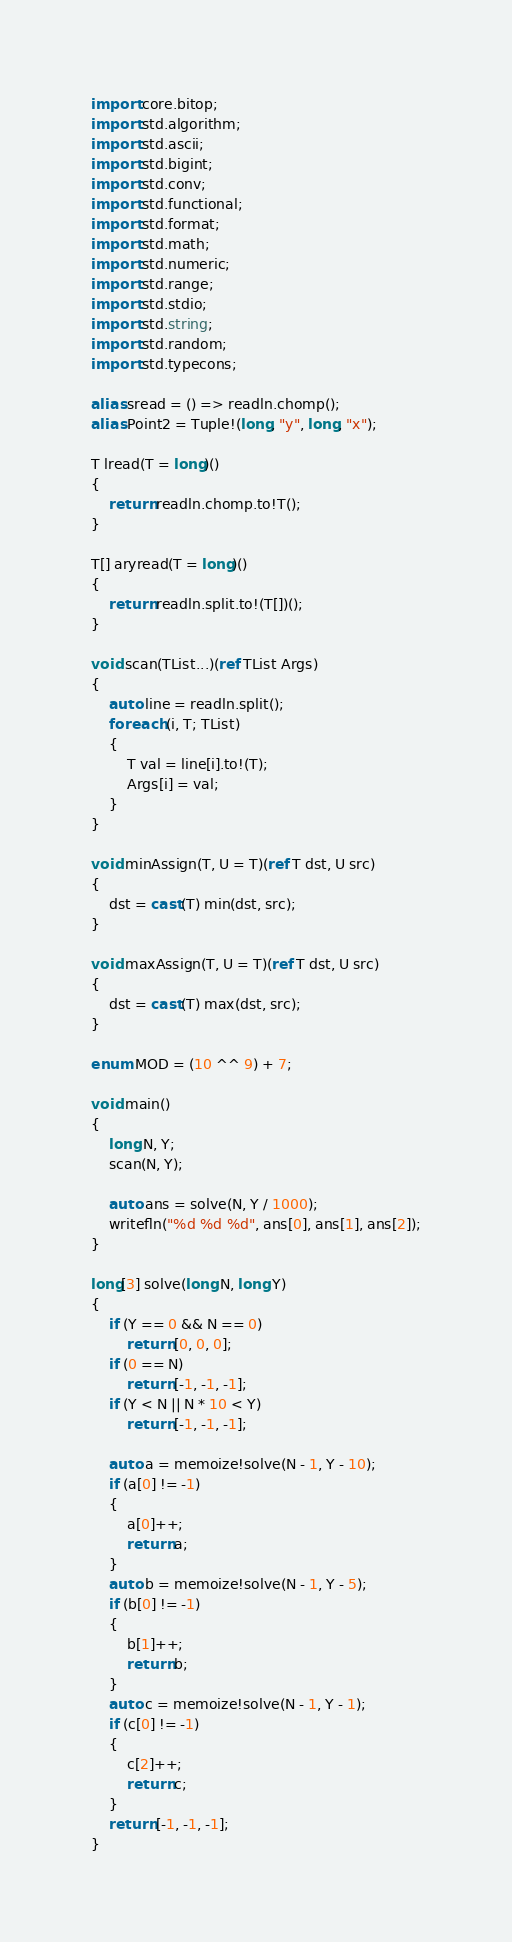<code> <loc_0><loc_0><loc_500><loc_500><_D_>import core.bitop;
import std.algorithm;
import std.ascii;
import std.bigint;
import std.conv;
import std.functional;
import std.format;
import std.math;
import std.numeric;
import std.range;
import std.stdio;
import std.string;
import std.random;
import std.typecons;

alias sread = () => readln.chomp();
alias Point2 = Tuple!(long, "y", long, "x");

T lread(T = long)()
{
    return readln.chomp.to!T();
}

T[] aryread(T = long)()
{
    return readln.split.to!(T[])();
}

void scan(TList...)(ref TList Args)
{
    auto line = readln.split();
    foreach (i, T; TList)
    {
        T val = line[i].to!(T);
        Args[i] = val;
    }
}

void minAssign(T, U = T)(ref T dst, U src)
{
    dst = cast(T) min(dst, src);
}

void maxAssign(T, U = T)(ref T dst, U src)
{
    dst = cast(T) max(dst, src);
}

enum MOD = (10 ^^ 9) + 7;

void main()
{
    long N, Y;
    scan(N, Y);

    auto ans = solve(N, Y / 1000);
    writefln("%d %d %d", ans[0], ans[1], ans[2]);
}

long[3] solve(long N, long Y)
{
    if (Y == 0 && N == 0)
        return [0, 0, 0];
    if (0 == N)
        return [-1, -1, -1];
    if (Y < N || N * 10 < Y)
        return [-1, -1, -1];

    auto a = memoize!solve(N - 1, Y - 10);
    if (a[0] != -1)
    {
        a[0]++;
        return a;
    }
    auto b = memoize!solve(N - 1, Y - 5);
    if (b[0] != -1)
    {
        b[1]++;
        return b;
    }
    auto c = memoize!solve(N - 1, Y - 1);
    if (c[0] != -1)
    {
        c[2]++;
        return c;
    }
    return [-1, -1, -1];
}
</code> 